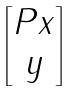<formula> <loc_0><loc_0><loc_500><loc_500>\begin{bmatrix} P x \\ y \end{bmatrix}</formula> 